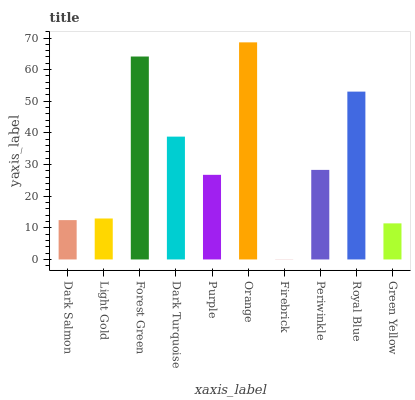Is Firebrick the minimum?
Answer yes or no. Yes. Is Orange the maximum?
Answer yes or no. Yes. Is Light Gold the minimum?
Answer yes or no. No. Is Light Gold the maximum?
Answer yes or no. No. Is Light Gold greater than Dark Salmon?
Answer yes or no. Yes. Is Dark Salmon less than Light Gold?
Answer yes or no. Yes. Is Dark Salmon greater than Light Gold?
Answer yes or no. No. Is Light Gold less than Dark Salmon?
Answer yes or no. No. Is Periwinkle the high median?
Answer yes or no. Yes. Is Purple the low median?
Answer yes or no. Yes. Is Light Gold the high median?
Answer yes or no. No. Is Dark Salmon the low median?
Answer yes or no. No. 